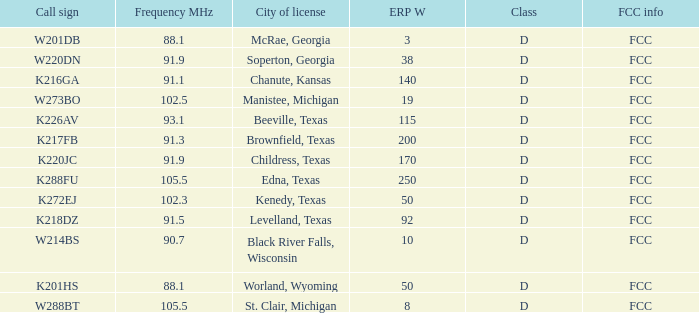What is Call Sign, when City of License is Brownfield, Texas? K217FB. 